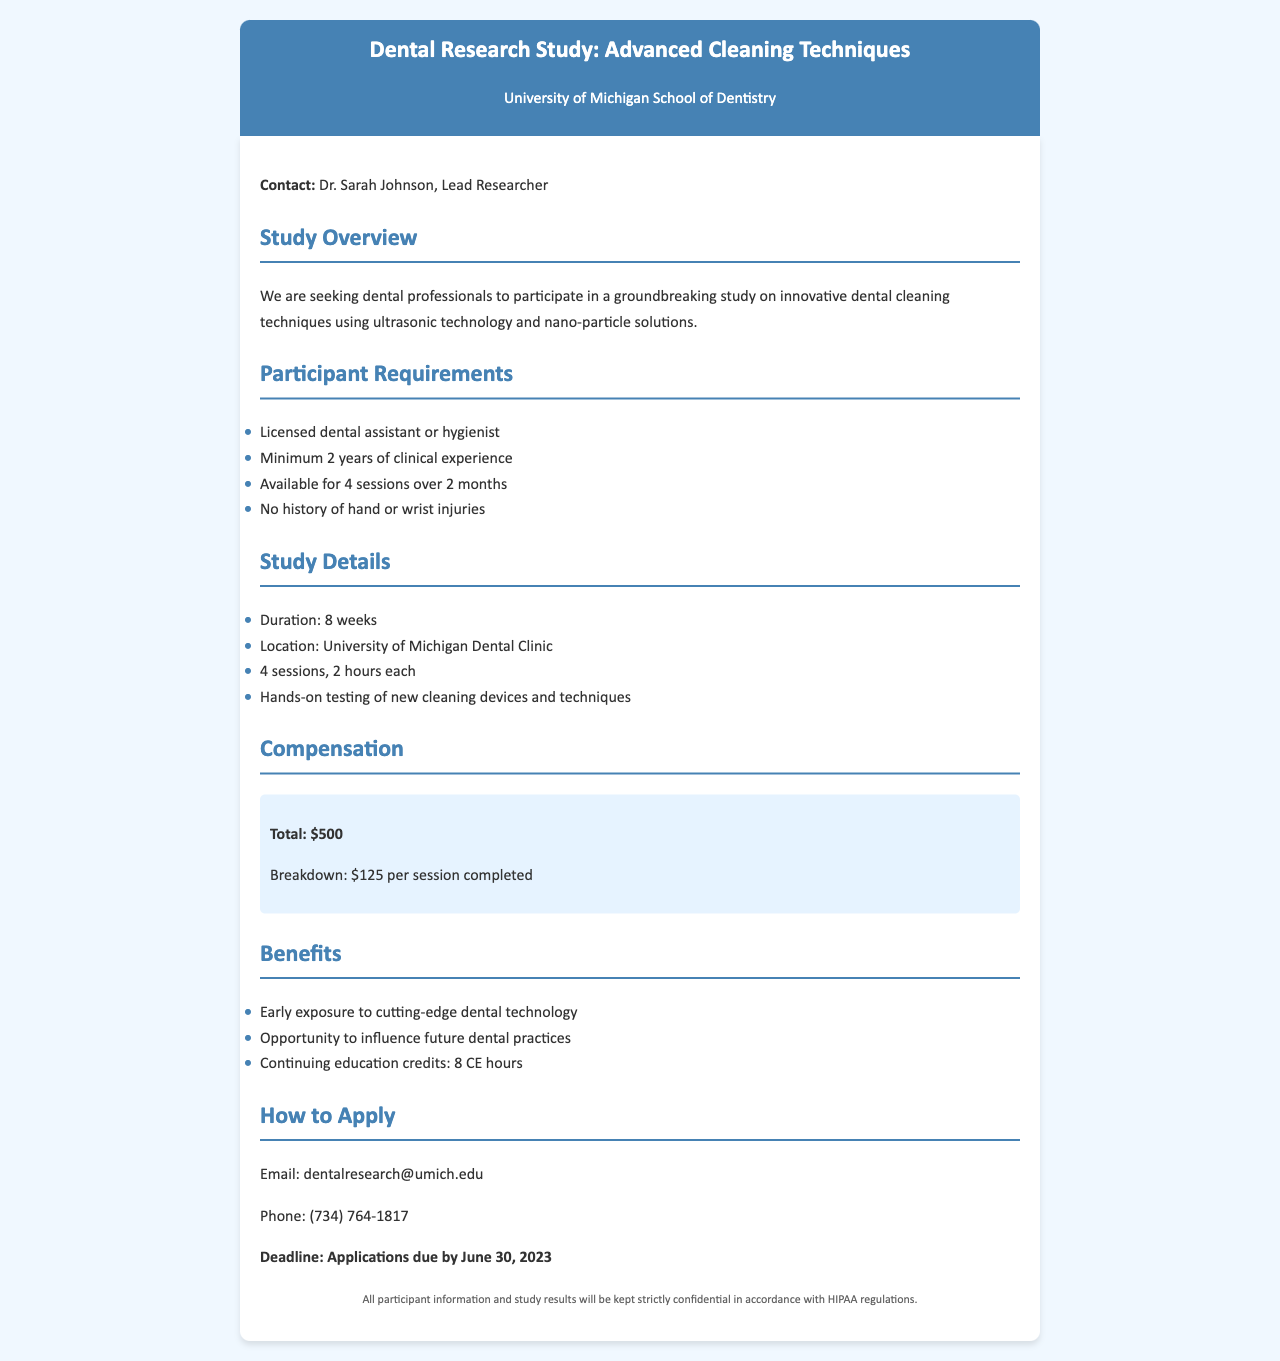What is the title of the study? The title of the study is mentioned at the top of the document.
Answer: Advanced Cleaning Techniques Who is the lead researcher? The document specifies the name of the lead researcher associated with the study.
Answer: Dr. Sarah Johnson What is the minimum clinical experience required? The requirements section states the minimum years of clinical experience needed for participation.
Answer: 2 years How many sessions are included in the study? The study details section lists the number of sessions that participants need to attend.
Answer: 4 sessions What is the compensation for each completed session? The compensation section provides a breakdown of the payment per session for participants.
Answer: $125 What is the total compensation for the study? The total compensation is specified in the compensation section of the document.
Answer: $500 What are the continuing education credits offered? The benefits section mentions the number of CE hours participants will receive.
Answer: 8 CE hours What is the application deadline? The document specifies when applications must be submitted.
Answer: June 30, 2023 Where will the study take place? The study details section indicates the location of the study.
Answer: University of Michigan Dental Clinic 